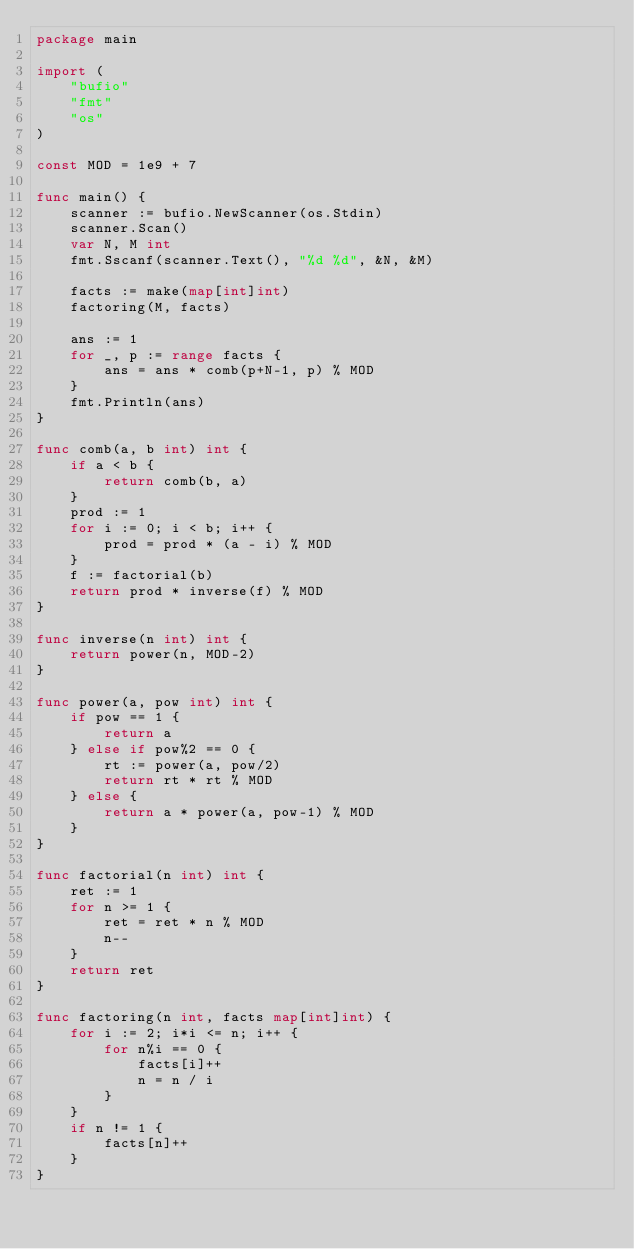<code> <loc_0><loc_0><loc_500><loc_500><_Go_>package main

import (
	"bufio"
	"fmt"
	"os"
)

const MOD = 1e9 + 7

func main() {
	scanner := bufio.NewScanner(os.Stdin)
	scanner.Scan()
	var N, M int
	fmt.Sscanf(scanner.Text(), "%d %d", &N, &M)

	facts := make(map[int]int)
	factoring(M, facts)

	ans := 1
	for _, p := range facts {
		ans = ans * comb(p+N-1, p) % MOD
	}
	fmt.Println(ans)
}

func comb(a, b int) int {
	if a < b {
		return comb(b, a)
	}
	prod := 1
	for i := 0; i < b; i++ {
		prod = prod * (a - i) % MOD
	}
	f := factorial(b)
	return prod * inverse(f) % MOD
}

func inverse(n int) int {
	return power(n, MOD-2)
}

func power(a, pow int) int {
	if pow == 1 {
		return a
	} else if pow%2 == 0 {
		rt := power(a, pow/2)
		return rt * rt % MOD
	} else {
		return a * power(a, pow-1) % MOD
	}
}

func factorial(n int) int {
	ret := 1
	for n >= 1 {
		ret = ret * n % MOD
		n--
	}
	return ret
}

func factoring(n int, facts map[int]int) {
	for i := 2; i*i <= n; i++ {
		for n%i == 0 {
			facts[i]++
			n = n / i
		}
	}
	if n != 1 {
		facts[n]++
	}
}
</code> 